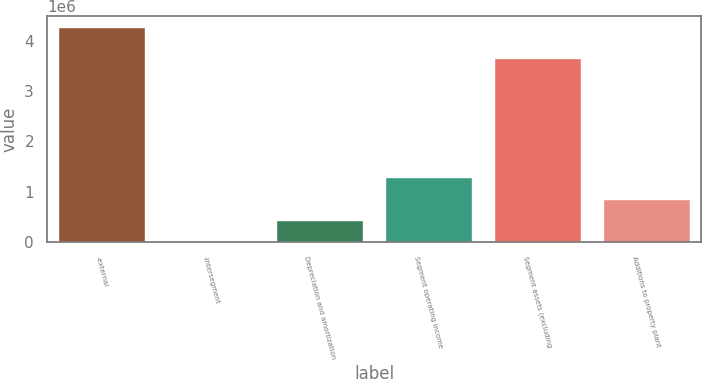<chart> <loc_0><loc_0><loc_500><loc_500><bar_chart><fcel>-external<fcel>-intersegment<fcel>Depreciation and amortization<fcel>Segment operating income<fcel>Segment assets (excluding<fcel>Additions to property plant<nl><fcel>4.26898e+06<fcel>5460<fcel>431812<fcel>1.28452e+06<fcel>3.64803e+06<fcel>858164<nl></chart> 